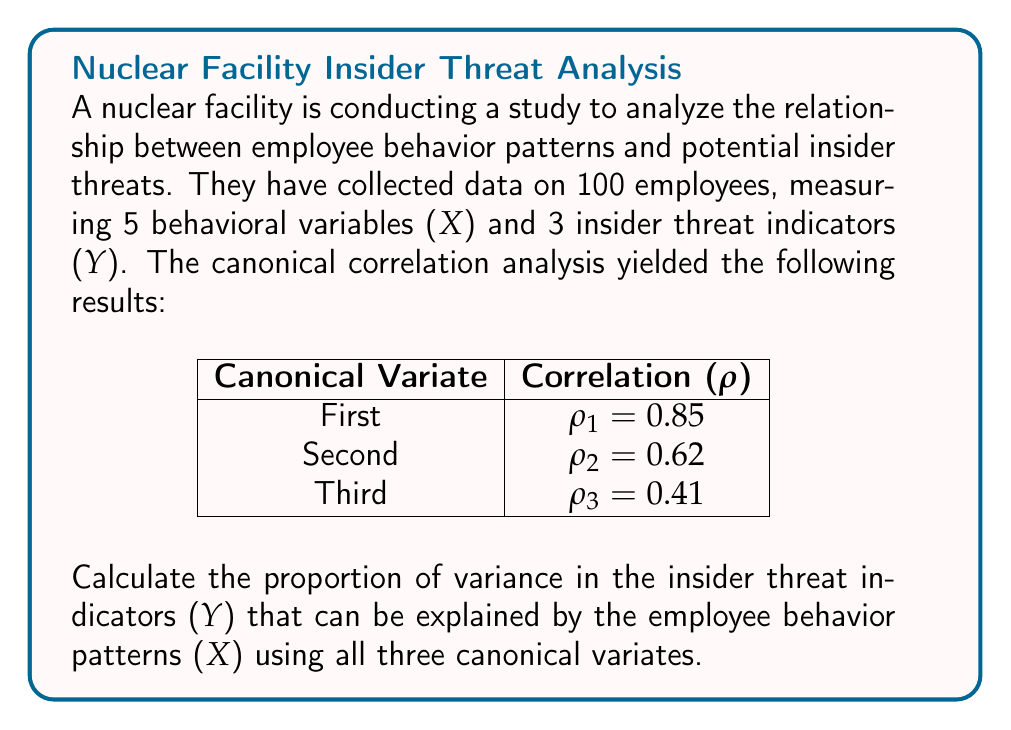Can you solve this math problem? To solve this problem, we need to follow these steps:

1) The proportion of variance explained by all canonical variates is given by the average of the squared canonical correlations.

2) We have three canonical correlations:
   $\rho_1 = 0.85$
   $\rho_2 = 0.62$
   $\rho_3 = 0.41$

3) We need to square each of these correlations:
   $\rho_1^2 = 0.85^2 = 0.7225$
   $\rho_2^2 = 0.62^2 = 0.3844$
   $\rho_3^2 = 0.41^2 = 0.1681$

4) Now, we need to calculate the average of these squared correlations:

   $$\text{Average } = \frac{\rho_1^2 + \rho_2^2 + \rho_3^2}{3}$$

5) Substituting the values:

   $$\text{Average } = \frac{0.7225 + 0.3844 + 0.1681}{3} = \frac{1.2750}{3} = 0.4250$$

6) Therefore, the proportion of variance in the insider threat indicators (Y) that can be explained by the employee behavior patterns (X) is 0.4250 or 42.50%.
Answer: 0.4250 or 42.50% 